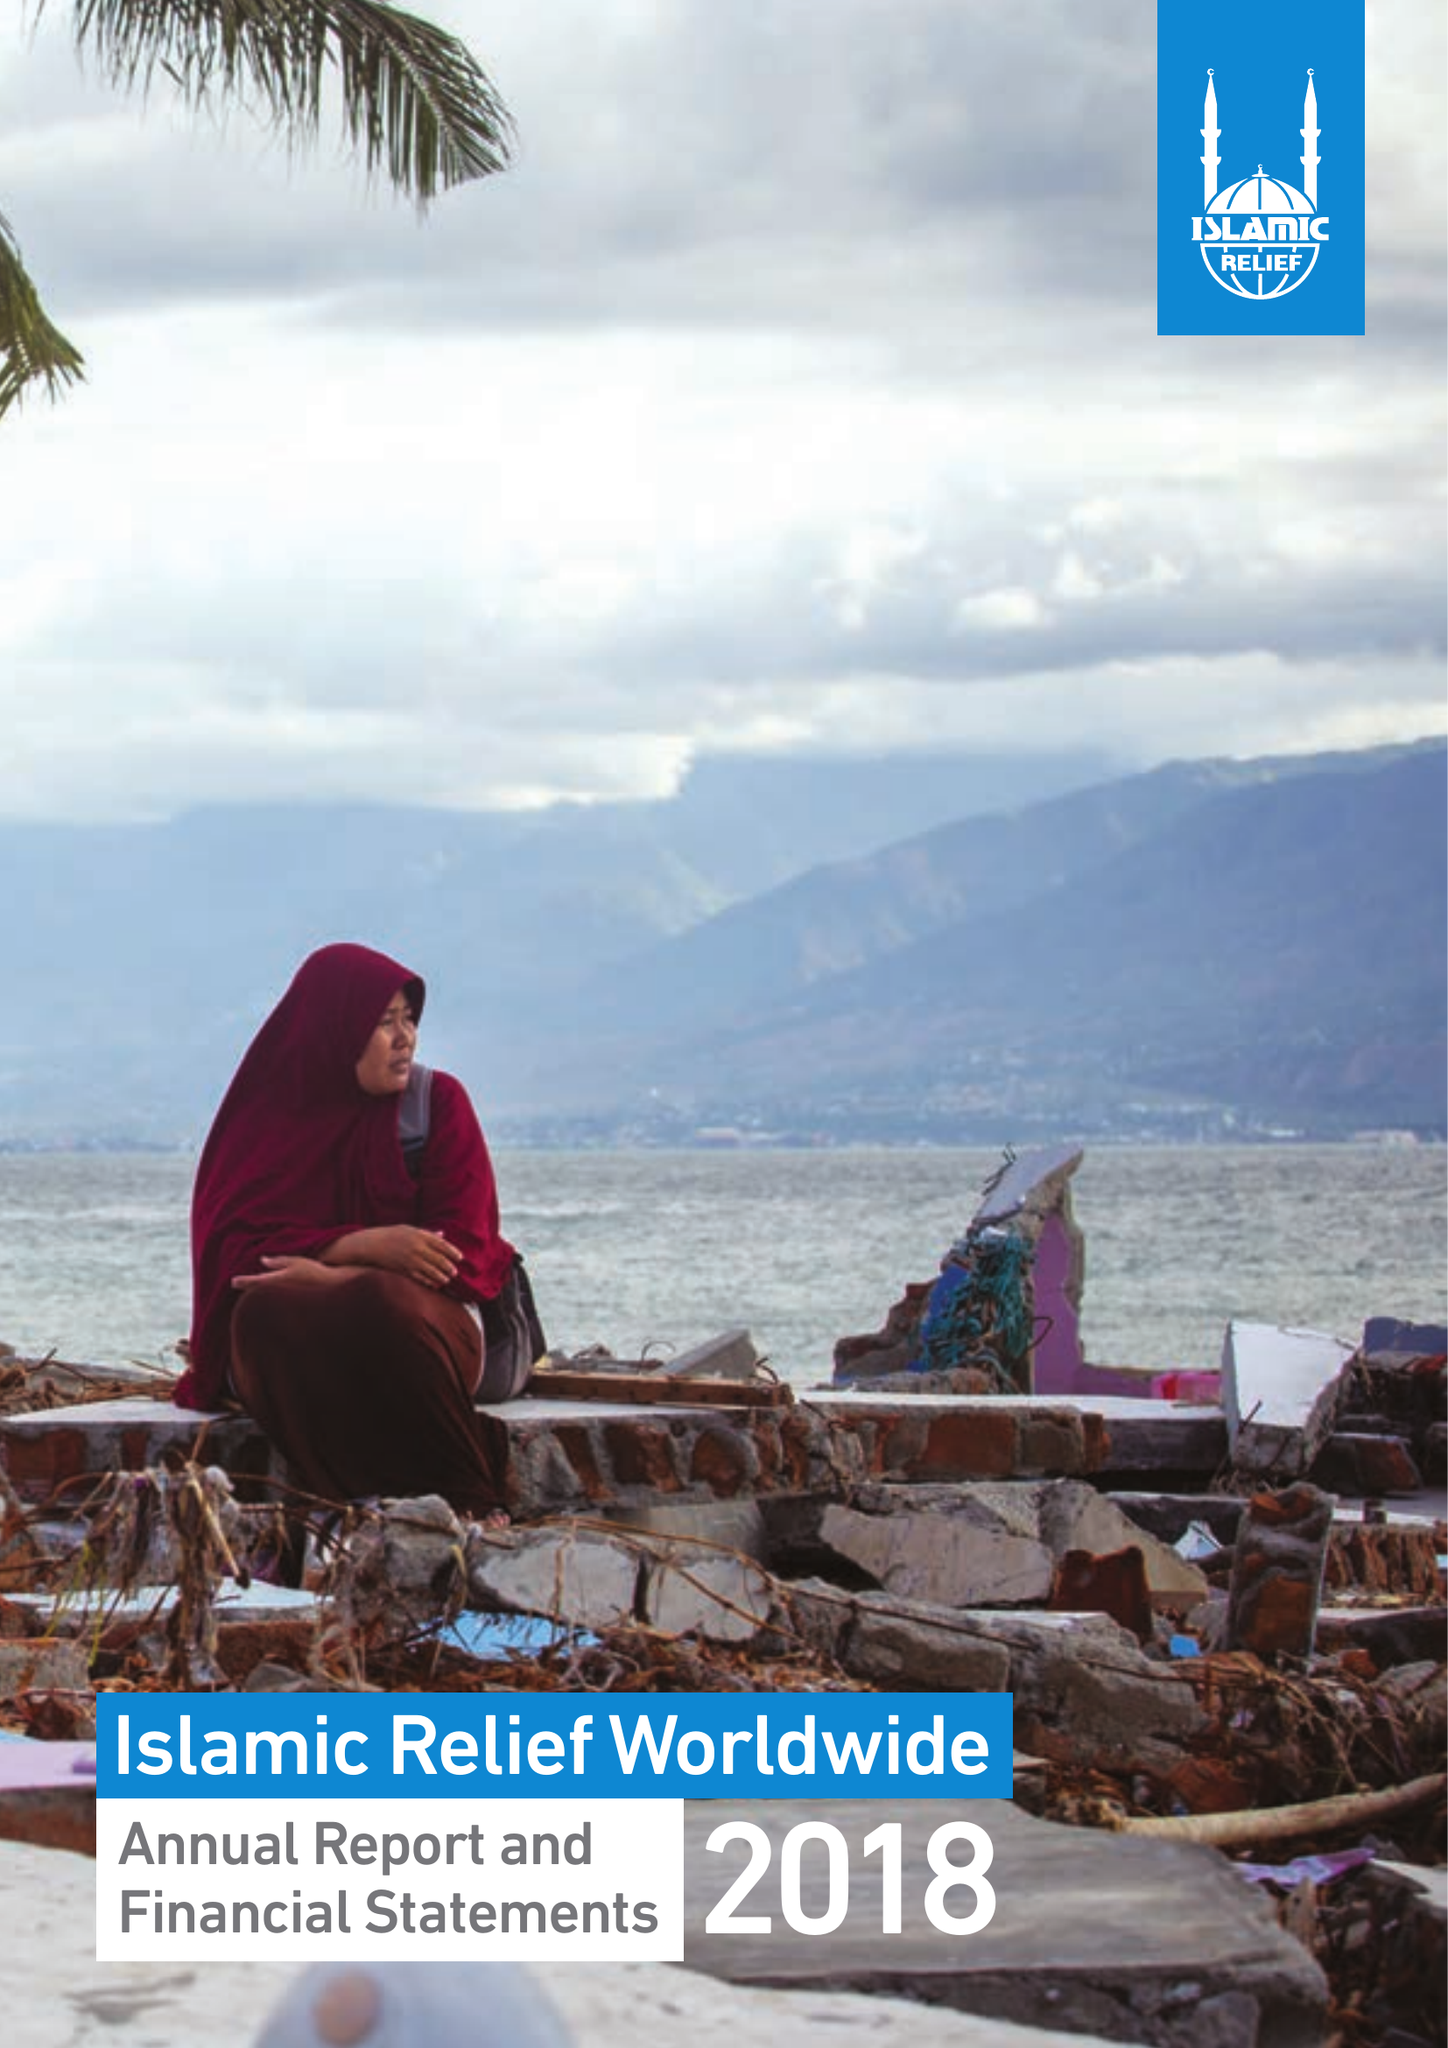What is the value for the report_date?
Answer the question using a single word or phrase. 2018-12-31 